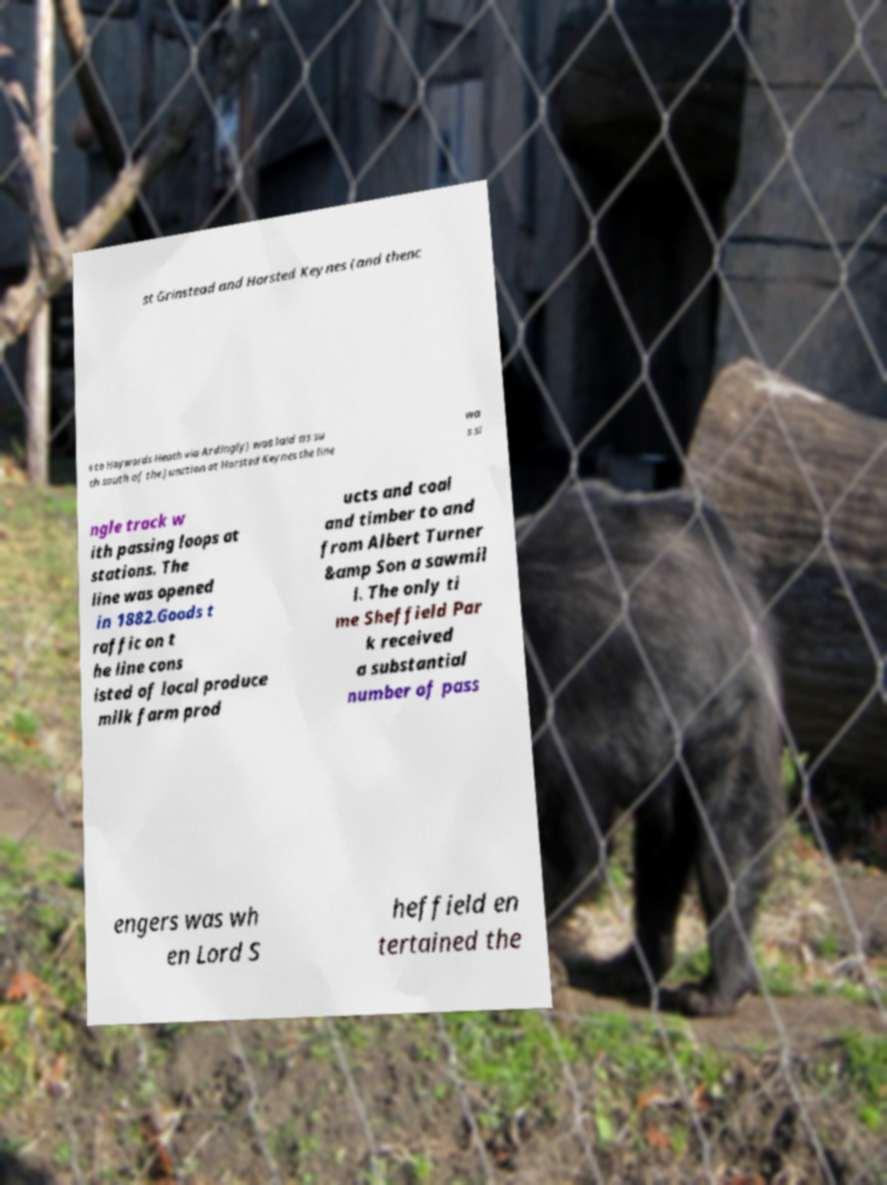There's text embedded in this image that I need extracted. Can you transcribe it verbatim? st Grinstead and Horsted Keynes (and thenc e to Haywards Heath via Ardingly) was laid as su ch south of the junction at Horsted Keynes the line wa s si ngle track w ith passing loops at stations. The line was opened in 1882.Goods t raffic on t he line cons isted of local produce milk farm prod ucts and coal and timber to and from Albert Turner &amp Son a sawmil l. The only ti me Sheffield Par k received a substantial number of pass engers was wh en Lord S heffield en tertained the 